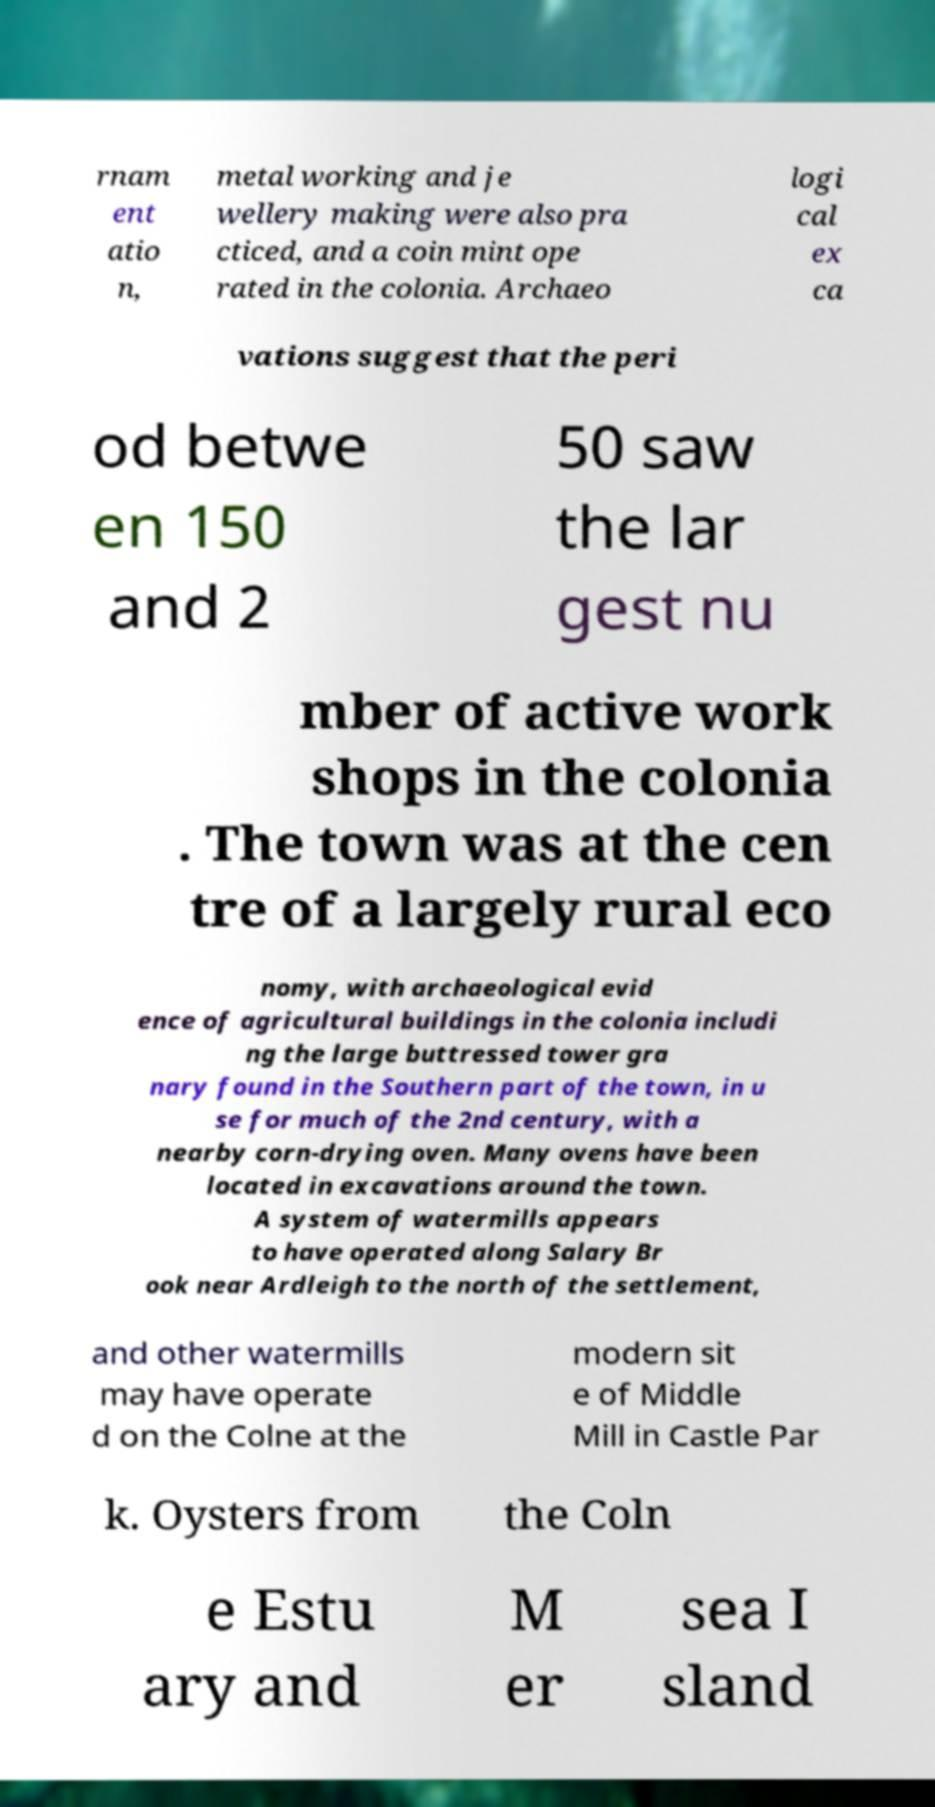Could you extract and type out the text from this image? rnam ent atio n, metal working and je wellery making were also pra cticed, and a coin mint ope rated in the colonia. Archaeo logi cal ex ca vations suggest that the peri od betwe en 150 and 2 50 saw the lar gest nu mber of active work shops in the colonia . The town was at the cen tre of a largely rural eco nomy, with archaeological evid ence of agricultural buildings in the colonia includi ng the large buttressed tower gra nary found in the Southern part of the town, in u se for much of the 2nd century, with a nearby corn-drying oven. Many ovens have been located in excavations around the town. A system of watermills appears to have operated along Salary Br ook near Ardleigh to the north of the settlement, and other watermills may have operate d on the Colne at the modern sit e of Middle Mill in Castle Par k. Oysters from the Coln e Estu ary and M er sea I sland 